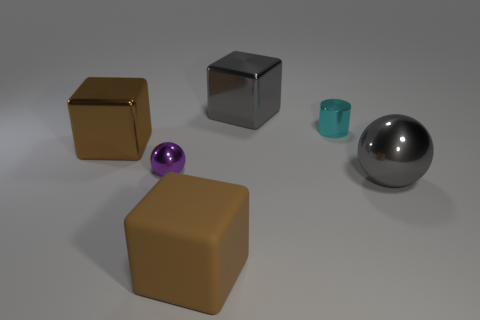How do the objects relate to each other in terms of positioning? In terms of positioning, the objects are spaced out in a linear fashion on a flat surface with no apparent overlap. The brown cube is to the furthermost left, followed by the shiny cube, the purple sphere, the cyan cylinder, and then the large metallic sphere on the right.  Is there a sense of balance in the composition of these objects? The composition presents a visual balance with symmetry in shapes and an orderly arrangement. The objects are equidistant and vary in texture and color, providing both harmony and contrast within the scene. 